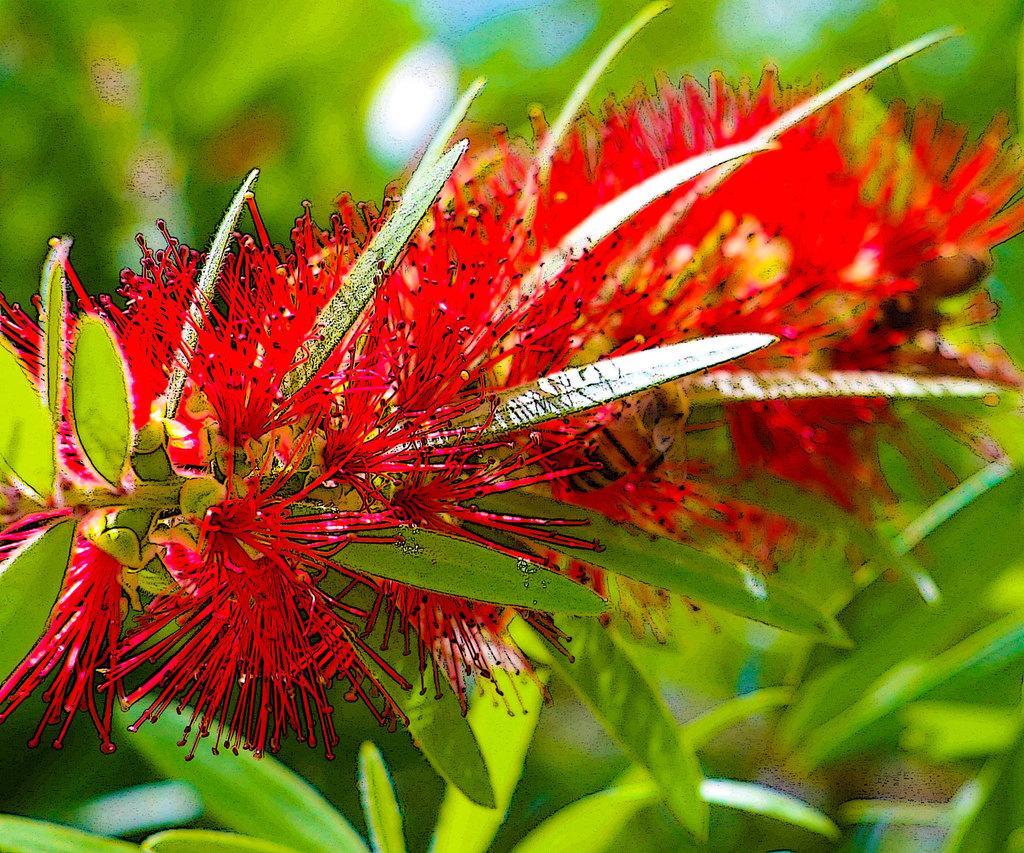How would you summarize this image in a sentence or two? In the picture we can see plants with leaves and some flowers which are red in color with thorn petals. 